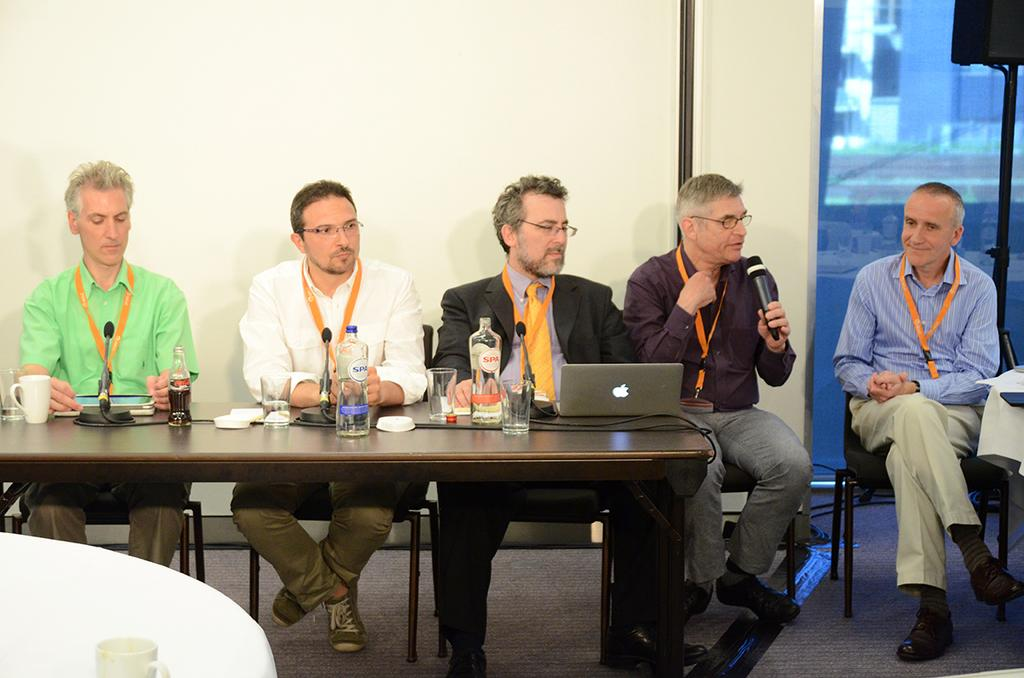How many men are present in the image? There are five men in the image. What are the men doing in the image? The men are sitting on chairs. What objects can be seen on the table in the image? There is a laptop, bottles, a microphone, and glasses on the table. What can be seen in the background of the image? There is a wall and a glass door in the background. What type of square is being used to write on the table in the image? There is no square present on the table in the image, and no one is writing on it. What experience can be gained from the pen in the image? There is no pen present in the image, so no experience can be gained from it. 